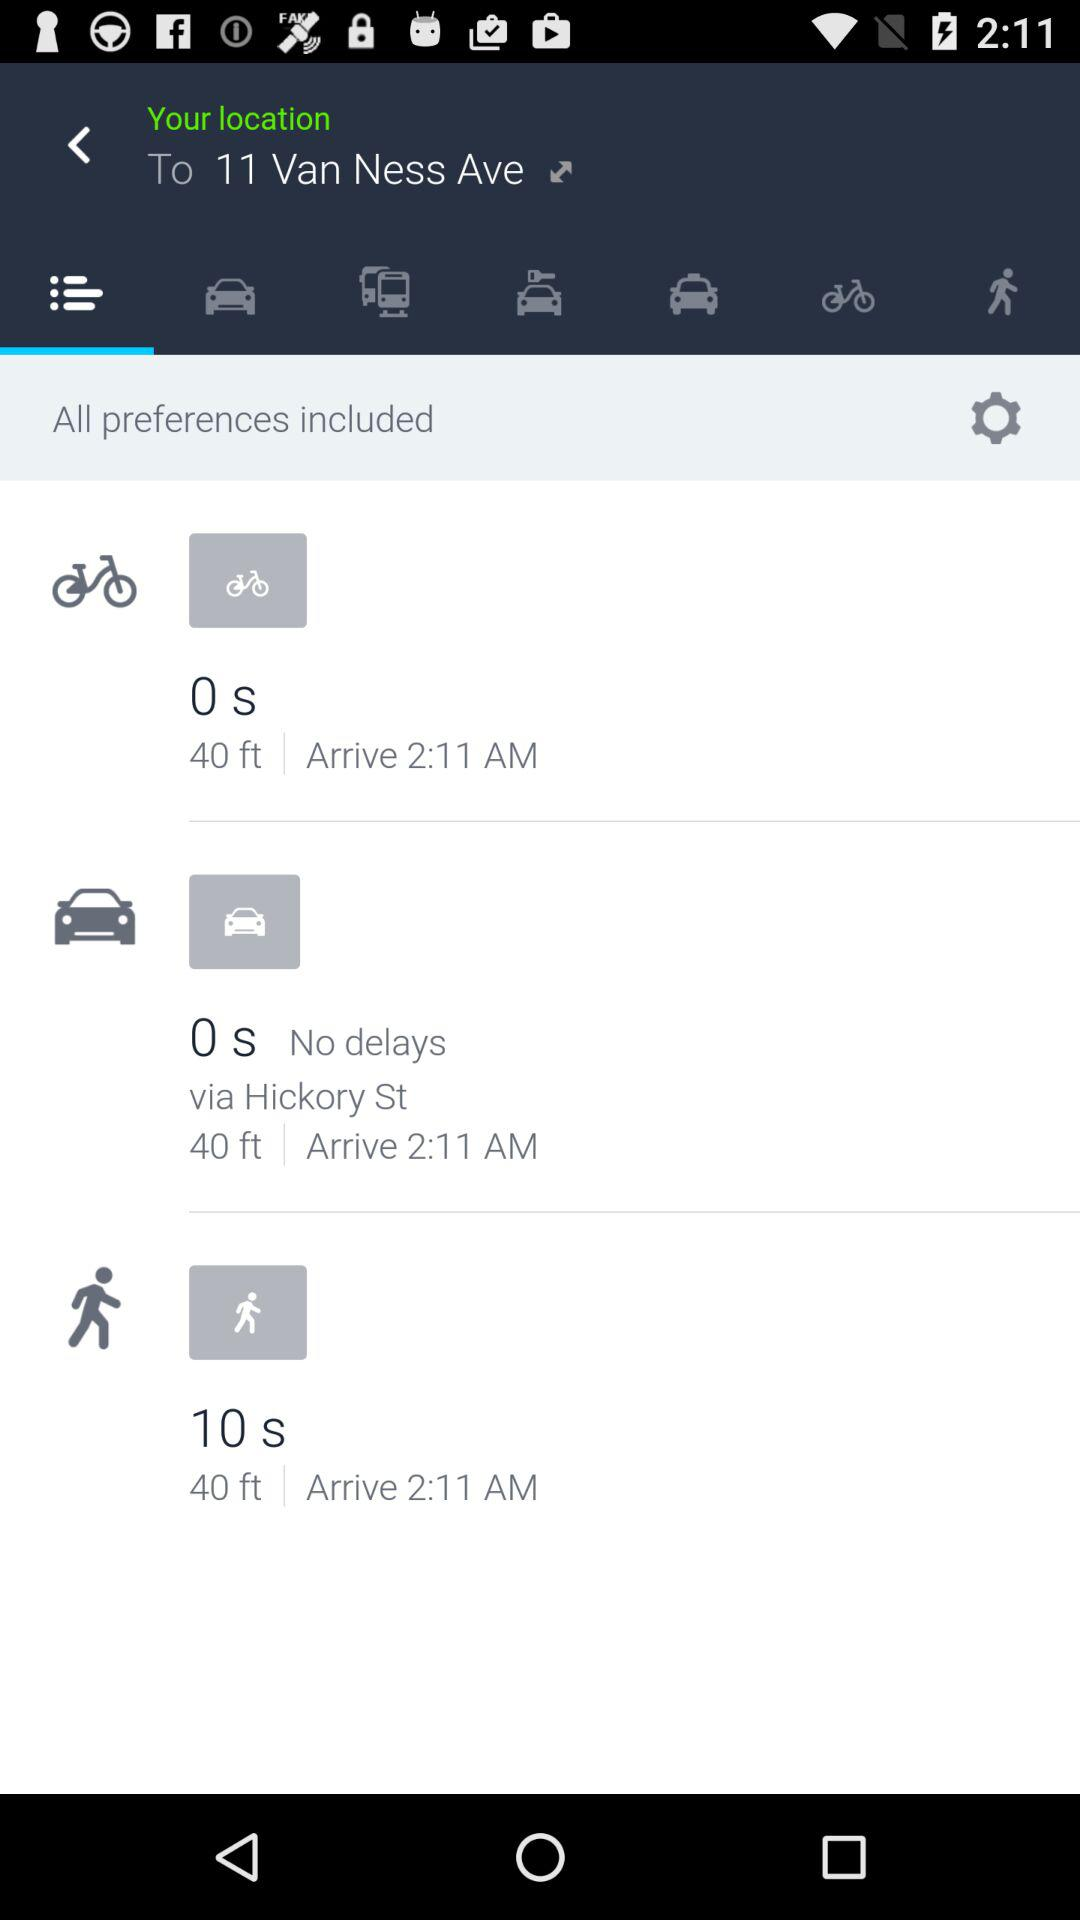How many more seconds does it take to walk to the destination than to drive?
Answer the question using a single word or phrase. 10 